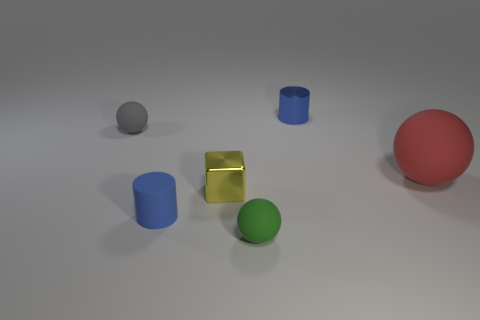Add 2 tiny purple matte cylinders. How many objects exist? 8 Subtract all blocks. How many objects are left? 5 Add 4 blue cylinders. How many blue cylinders are left? 6 Add 2 matte objects. How many matte objects exist? 6 Subtract 0 green cylinders. How many objects are left? 6 Subtract all gray matte things. Subtract all metallic objects. How many objects are left? 3 